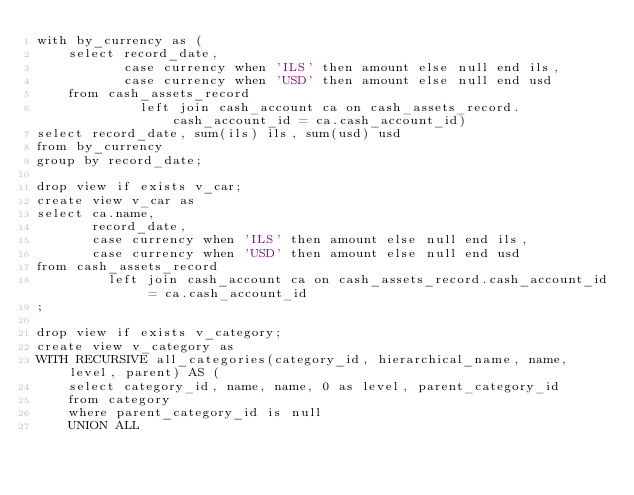Convert code to text. <code><loc_0><loc_0><loc_500><loc_500><_SQL_>with by_currency as (
    select record_date,
           case currency when 'ILS' then amount else null end ils,
           case currency when 'USD' then amount else null end usd
    from cash_assets_record
             left join cash_account ca on cash_assets_record.cash_account_id = ca.cash_account_id)
select record_date, sum(ils) ils, sum(usd) usd
from by_currency
group by record_date;

drop view if exists v_car;
create view v_car as
select ca.name,
       record_date,
       case currency when 'ILS' then amount else null end ils,
       case currency when 'USD' then amount else null end usd
from cash_assets_record
         left join cash_account ca on cash_assets_record.cash_account_id = ca.cash_account_id
;

drop view if exists v_category;
create view v_category as
WITH RECURSIVE all_categories(category_id, hierarchical_name, name, level, parent) AS (
    select category_id, name, name, 0 as level, parent_category_id
    from category
    where parent_category_id is null
    UNION ALL</code> 